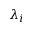<formula> <loc_0><loc_0><loc_500><loc_500>\lambda _ { i }</formula> 